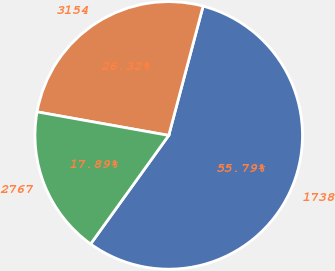Convert chart to OTSL. <chart><loc_0><loc_0><loc_500><loc_500><pie_chart><fcel>1738<fcel>3154<fcel>2767<nl><fcel>55.79%<fcel>26.32%<fcel>17.89%<nl></chart> 